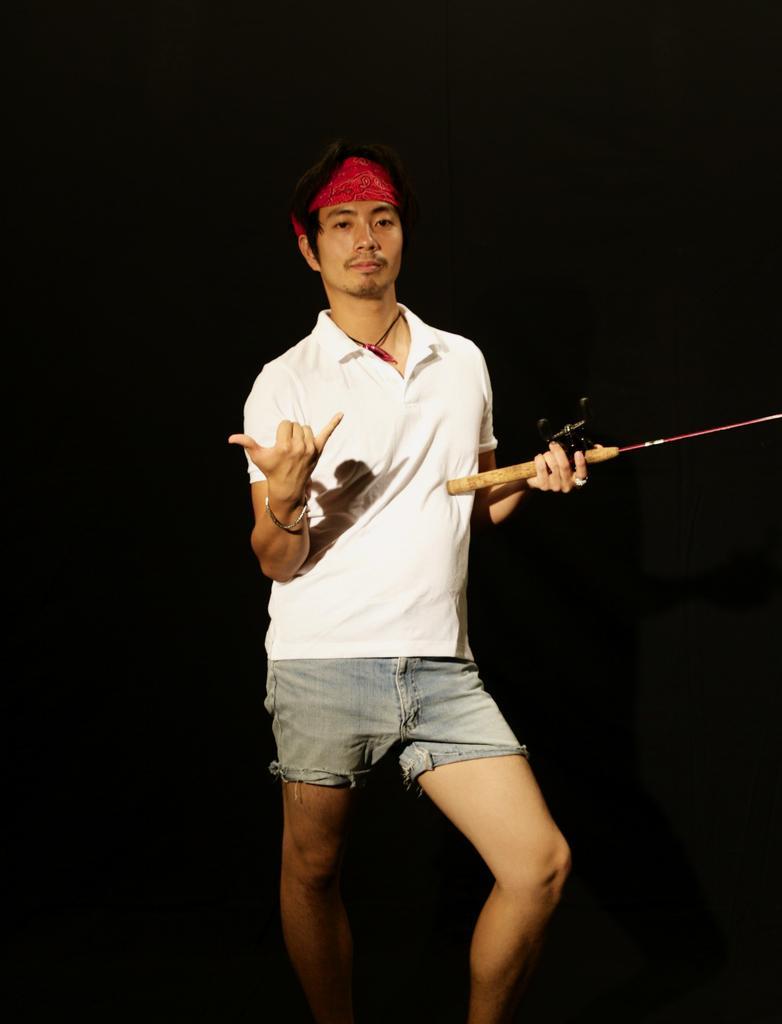Could you give a brief overview of what you see in this image? In this image there is a man who is standing by holding the stick with one hand and showing the fingers of another hand. He is wearing the headband. 